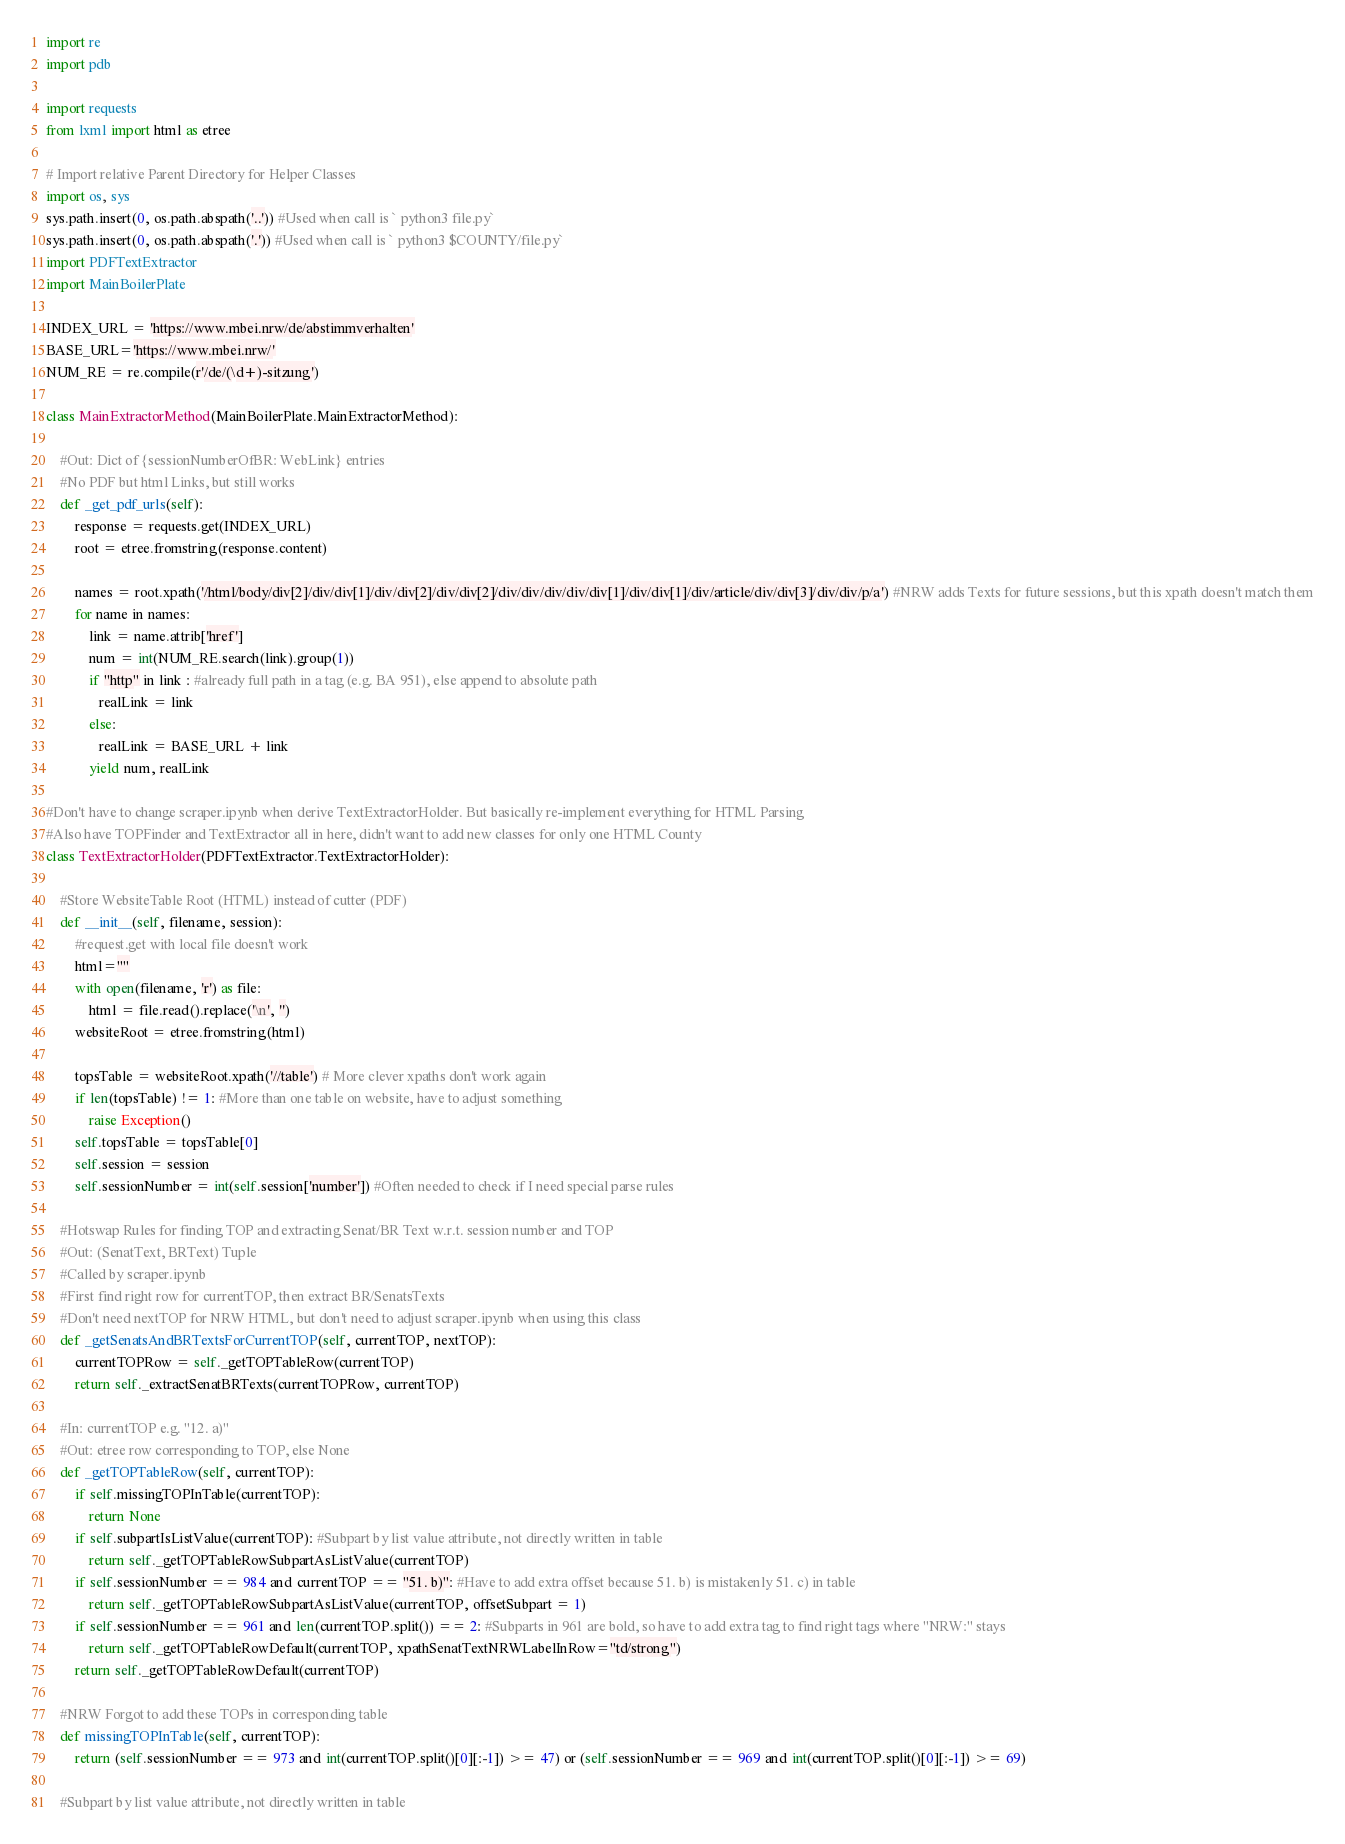<code> <loc_0><loc_0><loc_500><loc_500><_Python_>import re
import pdb

import requests
from lxml import html as etree

# Import relative Parent Directory for Helper Classes
import os, sys
sys.path.insert(0, os.path.abspath('..')) #Used when call is ` python3 file.py`
sys.path.insert(0, os.path.abspath('.')) #Used when call is ` python3 $COUNTY/file.py`
import PDFTextExtractor
import MainBoilerPlate

INDEX_URL = 'https://www.mbei.nrw/de/abstimmverhalten'
BASE_URL='https://www.mbei.nrw/'
NUM_RE = re.compile(r'/de/(\d+)-sitzung')

class MainExtractorMethod(MainBoilerPlate.MainExtractorMethod):

    #Out: Dict of {sessionNumberOfBR: WebLink} entries
    #No PDF but html Links, but still works
    def _get_pdf_urls(self):
        response = requests.get(INDEX_URL)
        root = etree.fromstring(response.content)

        names = root.xpath('/html/body/div[2]/div/div[1]/div/div[2]/div/div[2]/div/div/div/div/div[1]/div/div[1]/div/article/div/div[3]/div/div/p/a') #NRW adds Texts for future sessions, but this xpath doesn't match them
        for name in names:
            link = name.attrib['href']
            num = int(NUM_RE.search(link).group(1))
            if "http" in link : #already full path in a tag (e.g. BA 951), else append to absolute path
               realLink = link
            else:
               realLink = BASE_URL + link 
            yield num, realLink

#Don't have to change scraper.ipynb when derive TextExtractorHolder. But basically re-implement everything for HTML Parsing
#Also have TOPFinder and TextExtractor all in here, didn't want to add new classes for only one HTML County
class TextExtractorHolder(PDFTextExtractor.TextExtractorHolder):

    #Store WebsiteTable Root (HTML) instead of cutter (PDF)
    def __init__(self, filename, session):
        #request.get with local file doesn't work
        html=""
        with open(filename, 'r') as file:
            html = file.read().replace('\n', '') 
        websiteRoot = etree.fromstring(html)

        topsTable = websiteRoot.xpath('//table') # More clever xpaths don't work again
        if len(topsTable) != 1: #More than one table on website, have to adjust something
            raise Exception()
        self.topsTable = topsTable[0]
        self.session = session
        self.sessionNumber = int(self.session['number']) #Often needed to check if I need special parse rules

    #Hotswap Rules for finding TOP and extracting Senat/BR Text w.r.t. session number and TOP
    #Out: (SenatText, BRText) Tuple
    #Called by scraper.ipynb
    #First find right row for currentTOP, then extract BR/SenatsTexts
    #Don't need nextTOP for NRW HTML, but don't need to adjust scraper.ipynb when using this class
    def _getSenatsAndBRTextsForCurrentTOP(self, currentTOP, nextTOP):
        currentTOPRow = self._getTOPTableRow(currentTOP)
        return self._extractSenatBRTexts(currentTOPRow, currentTOP)

    #In: currentTOP e.g. "12. a)"
    #Out: etree row corresponding to TOP, else None
    def _getTOPTableRow(self, currentTOP):
        if self.missingTOPInTable(currentTOP):
            return None
        if self.subpartIsListValue(currentTOP): #Subpart by list value attribute, not directly written in table
            return self._getTOPTableRowSubpartAsListValue(currentTOP)
        if self.sessionNumber == 984 and currentTOP == "51. b)": #Have to add extra offset because 51. b) is mistakenly 51. c) in table
            return self._getTOPTableRowSubpartAsListValue(currentTOP, offsetSubpart = 1)
        if self.sessionNumber == 961 and len(currentTOP.split()) == 2: #Subparts in 961 are bold, so have to add extra tag to find right tags where "NRW:" stays
            return self._getTOPTableRowDefault(currentTOP, xpathSenatTextNRWLabelInRow="td/strong")
        return self._getTOPTableRowDefault(currentTOP)

    #NRW Forgot to add these TOPs in corresponding table
    def missingTOPInTable(self, currentTOP):
        return (self.sessionNumber == 973 and int(currentTOP.split()[0][:-1]) >= 47) or (self.sessionNumber == 969 and int(currentTOP.split()[0][:-1]) >= 69)

    #Subpart by list value attribute, not directly written in table</code> 